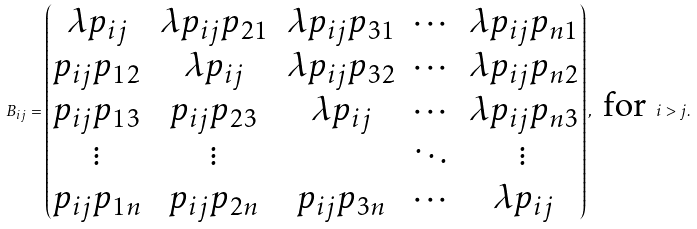Convert formula to latex. <formula><loc_0><loc_0><loc_500><loc_500>B _ { i j } = \begin{pmatrix} \lambda p _ { i j } & \lambda p _ { i j } p _ { 2 1 } & \lambda p _ { i j } p _ { 3 1 } & \cdots & \lambda p _ { i j } p _ { n 1 } \\ p _ { i j } p _ { 1 2 } & \lambda p _ { i j } & \lambda p _ { i j } p _ { 3 2 } & \cdots & \lambda p _ { i j } p _ { n 2 } \\ p _ { i j } p _ { 1 3 } & p _ { i j } p _ { 2 3 } & \lambda p _ { i j } & \cdots & \lambda p _ { i j } p _ { n 3 } \\ \vdots & \vdots & & \ddots & \vdots \\ p _ { i j } p _ { 1 n } & p _ { i j } p _ { 2 n } & p _ { i j } p _ { 3 n } & \cdots & \lambda p _ { i j } \end{pmatrix} , \text { for } i > j .</formula> 